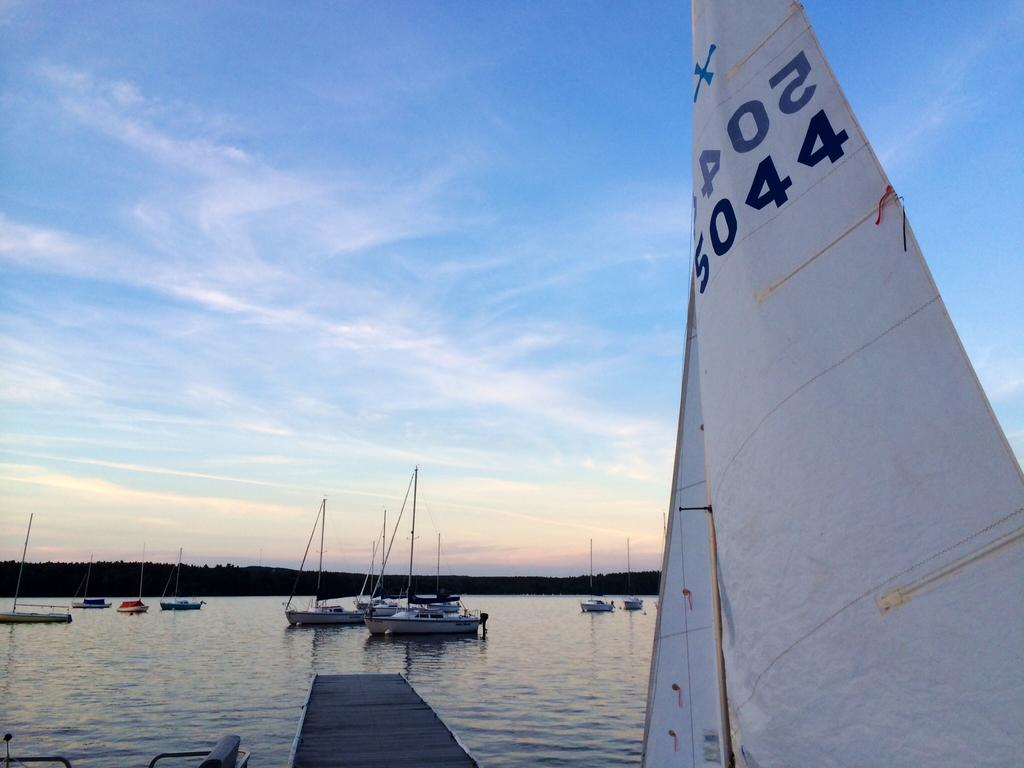What is in the water in the image? There are boats in the water. What can be seen in the background of the image? There are trees in the background. Can you describe the object in the right corner of the image? There is an object with writing in the right corner of the image. What type of texture can be seen on the guitar in the image? There is no guitar present in the image. Can you describe the cobweb on the tree in the background? There is no cobweb visible on the trees in the background of the image. 